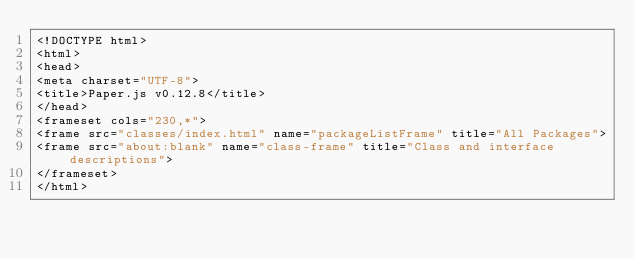Convert code to text. <code><loc_0><loc_0><loc_500><loc_500><_HTML_><!DOCTYPE html>
<html>
<head>
<meta charset="UTF-8">
<title>Paper.js v0.12.8</title>
</head>
<frameset cols="230,*">
<frame src="classes/index.html" name="packageListFrame" title="All Packages">
<frame src="about:blank" name="class-frame" title="Class and interface descriptions">
</frameset>
</html>
</code> 